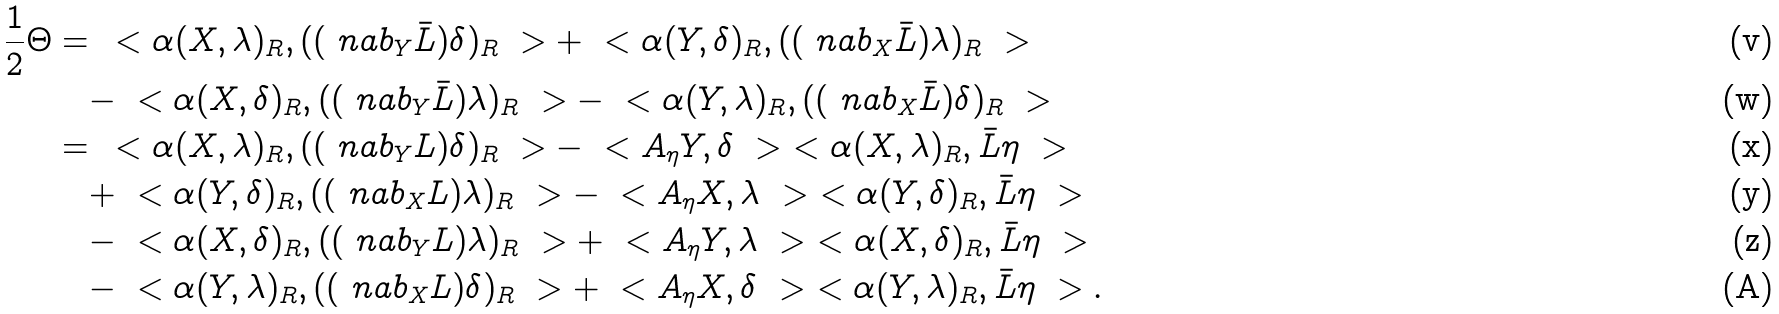<formula> <loc_0><loc_0><loc_500><loc_500>\frac { 1 } { 2 } \Theta = & \, \ < \alpha ( X , \lambda ) _ { R } , ( ( \ n a b _ { Y } \bar { L } ) \delta ) _ { R } \ > + \ < \alpha ( Y , \delta ) _ { R } , ( ( \ n a b _ { X } \bar { L } ) \lambda ) _ { R } \ > \\ & - \ < \alpha ( X , \delta ) _ { R } , ( ( \ n a b _ { Y } \bar { L } ) \lambda ) _ { R } \ > - \ < \alpha ( Y , \lambda ) _ { R } , ( ( \ n a b _ { X } \bar { L } ) \delta ) _ { R } \ > \\ = & \, \ < \alpha ( X , \lambda ) _ { R } , ( ( \ n a b _ { Y } L ) \delta ) _ { R } \ > - \ < A _ { \eta } Y , \delta \ > \ < \alpha ( X , \lambda ) _ { R } , \bar { L } \eta \ > \\ & + \ < \alpha ( Y , \delta ) _ { R } , ( ( \ n a b _ { X } L ) \lambda ) _ { R } \ > - \ < A _ { \eta } X , \lambda \ > \ < \alpha ( Y , \delta ) _ { R } , \bar { L } \eta \ > \\ & - \ < \alpha ( X , \delta ) _ { R } , ( ( \ n a b _ { Y } L ) \lambda ) _ { R } \ > + \ < A _ { \eta } Y , \lambda \ > \ < \alpha ( X , \delta ) _ { R } , \bar { L } \eta \ > \\ & - \ < \alpha ( Y , \lambda ) _ { R } , ( ( \ n a b _ { X } L ) \delta ) _ { R } \ > + \ < A _ { \eta } X , \delta \ > \ < \alpha ( Y , \lambda ) _ { R } , \bar { L } \eta \ > .</formula> 